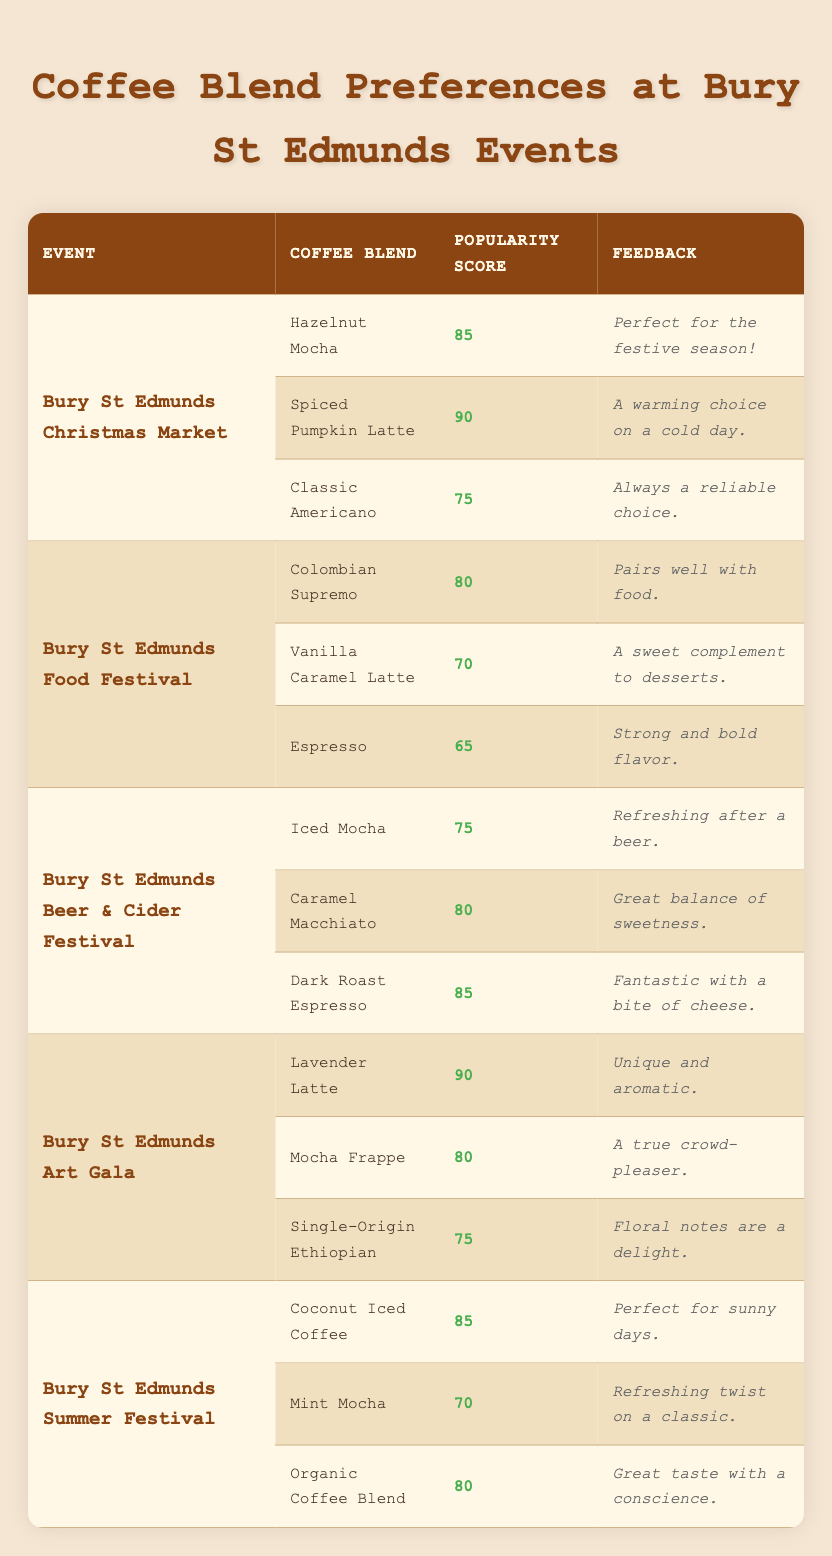What is the most popular coffee blend at the Bury St Edmunds Christmas Market? The most popular coffee blend at the Bury St Edmunds Christmas Market can be found by looking at the highest popularity score listed. The blends are Hazelnut Mocha (85), Spiced Pumpkin Latte (90), and Classic Americano (75). The highest score is 90 for the Spiced Pumpkin Latte.
Answer: Spiced Pumpkin Latte Which coffee blend received the lowest popularity score at the Bury St Edmunds Food Festival? To find the lowest popularity score at the Bury St Edmunds Food Festival, we look at the popularity scores for the coffee blends: Colombian Supremo (80), Vanilla Caramel Latte (70), and Espresso (65). The lowest score is 65 for Espresso.
Answer: Espresso Is Lavender Latte more popular than Hazelnut Mocha? We compare the popularity scores: Lavender Latte has a score of 90, and Hazelnut Mocha has a score of 85. Since 90 is greater than 85, Lavender Latte is indeed more popular.
Answer: Yes What is the average popularity score of coffee blends offered at the Bury St Edmunds Art Gala? The popularity scores for the coffee blends at the Bury St Edmunds Art Gala are: Lavender Latte (90), Mocha Frappe (80), and Single-Origin Ethiopian (75). The average can be calculated by adding these scores (90 + 80 + 75 = 245) and dividing by the number of blends (3), which gives us 245/3 = 81.67.
Answer: 81.67 Which coffee blends scored 85 or above at the Bury St Edmunds Beer & Cider Festival? At the Bury St Edmunds Beer & Cider Festival, the coffee blends and their scores are: Iced Mocha (75), Caramel Macchiato (80), and Dark Roast Espresso (85). The only blend that scored 85 or above is Dark Roast Espresso.
Answer: Dark Roast Espresso How many coffee blends received a popularity score of 70 or less across all events? We need to review each event and count blends with scores of 70 or less: Food Festival (Vanilla Caramel Latte 70, Espresso 65), Beer & Cider Festival (none), Art Gala (none), Summer Festival (Mint Mocha 70). In total, there are three blends: Vanilla Caramel Latte, Espresso, and Mint Mocha, which makes it three blends.
Answer: 3 Did the Coconut Iced Coffee receive a higher score than any coffee blend at the Bury St Edmunds Summer Festival? The popularity scores at the Bury St Edmunds Summer Festival are Coconut Iced Coffee (85), Mint Mocha (70), and Organic Coffee Blend (80). Since 85 is higher than both 70 and 80, it confirms that Coconut Iced Coffee is indeed the highest scored blend at this event.
Answer: Yes What is the total popularity score of all coffee blends at the Bury St Edmunds Christmas Market? The popularity scores for the Christmas Market are: Hazelnut Mocha (85), Spiced Pumpkin Latte (90), and Classic Americano (75). We sum these scores (85 + 90 + 75 = 250) to find the total popularity score.
Answer: 250 